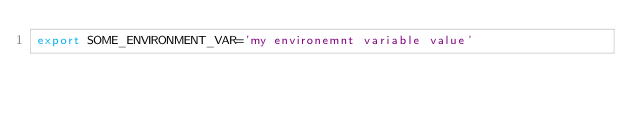Convert code to text. <code><loc_0><loc_0><loc_500><loc_500><_Bash_>export SOME_ENVIRONMENT_VAR='my environemnt variable value'
</code> 